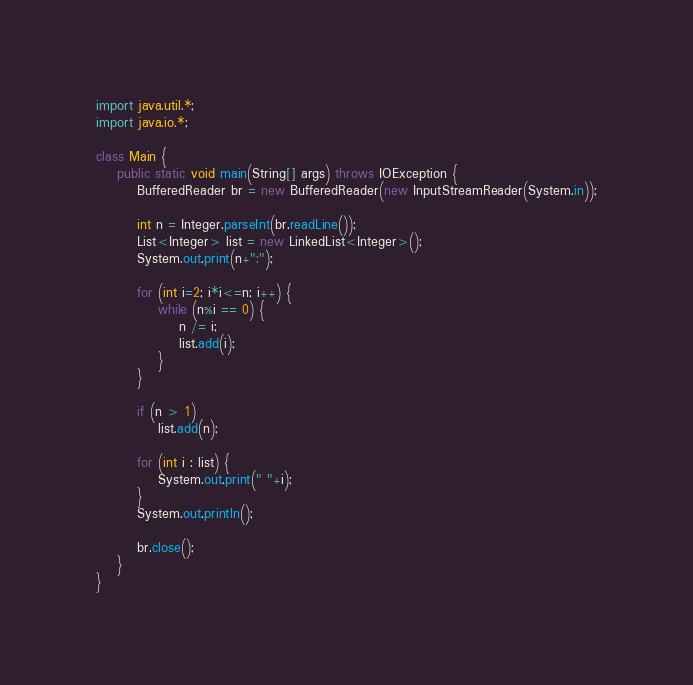<code> <loc_0><loc_0><loc_500><loc_500><_Java_>import java.util.*;
import java.io.*;

class Main {
	public static void main(String[] args) throws IOException {
		BufferedReader br = new BufferedReader(new InputStreamReader(System.in));

		int n = Integer.parseInt(br.readLine());
		List<Integer> list = new LinkedList<Integer>();
		System.out.print(n+":");

		for (int i=2; i*i<=n; i++) {
			while (n%i == 0) {
				n /= i;
				list.add(i);
			}
		}

		if (n > 1)
			list.add(n);

		for (int i : list) {
			System.out.print(" "+i);
		}
		System.out.println();

		br.close();
	}
}</code> 